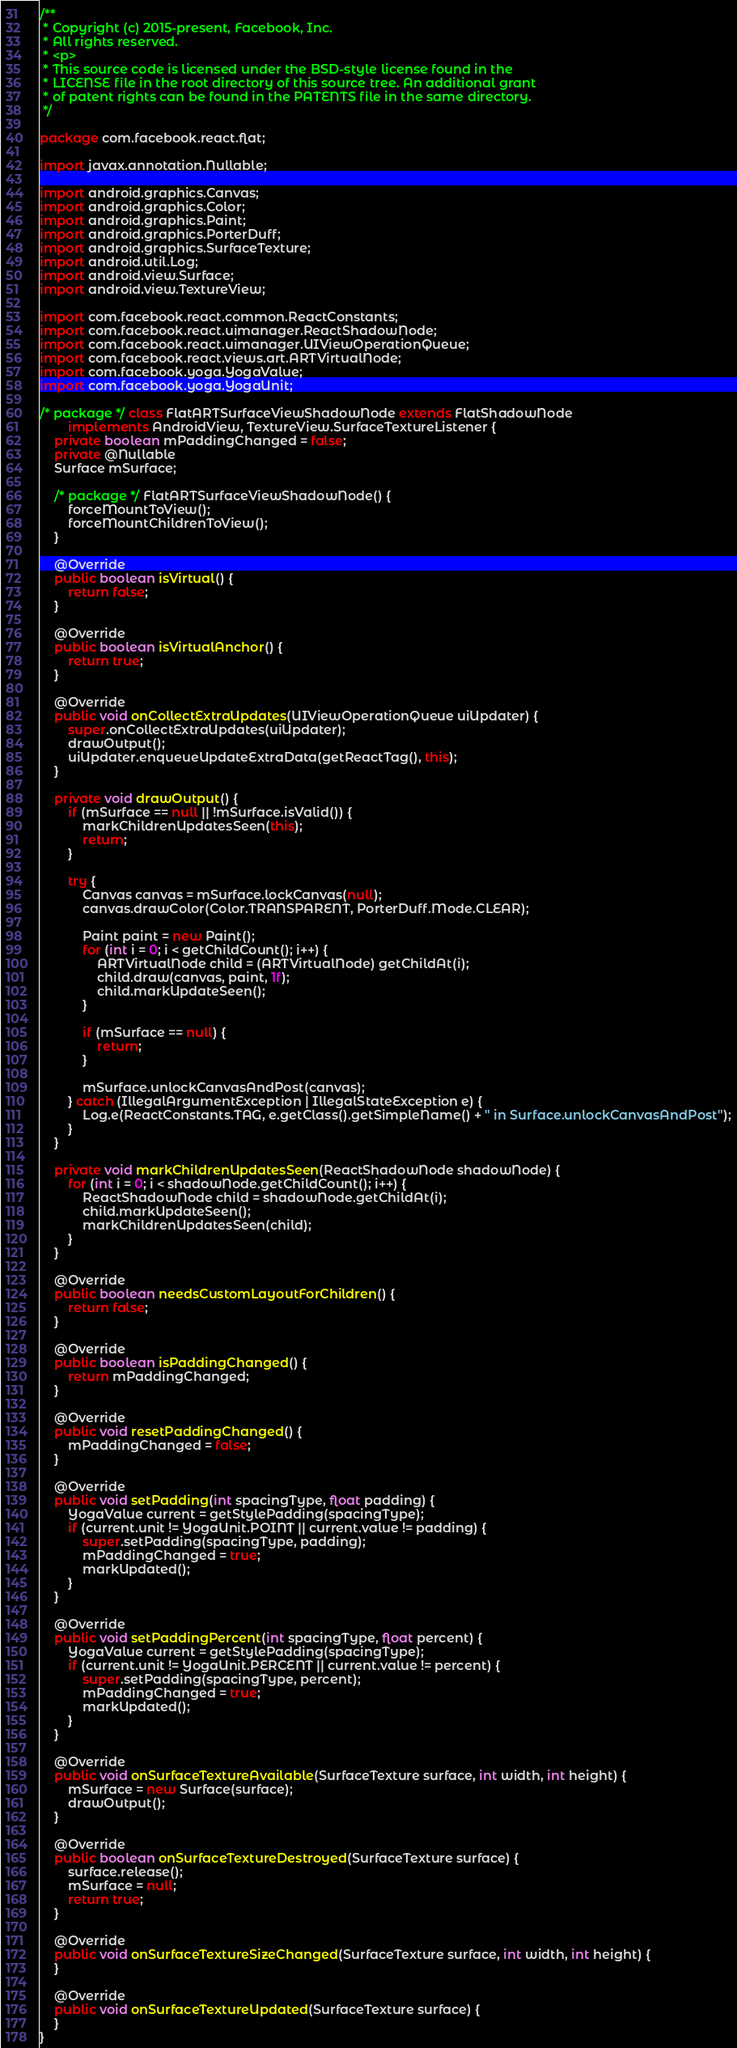<code> <loc_0><loc_0><loc_500><loc_500><_Java_>/**
 * Copyright (c) 2015-present, Facebook, Inc.
 * All rights reserved.
 * <p>
 * This source code is licensed under the BSD-style license found in the
 * LICENSE file in the root directory of this source tree. An additional grant
 * of patent rights can be found in the PATENTS file in the same directory.
 */

package com.facebook.react.flat;

import javax.annotation.Nullable;

import android.graphics.Canvas;
import android.graphics.Color;
import android.graphics.Paint;
import android.graphics.PorterDuff;
import android.graphics.SurfaceTexture;
import android.util.Log;
import android.view.Surface;
import android.view.TextureView;

import com.facebook.react.common.ReactConstants;
import com.facebook.react.uimanager.ReactShadowNode;
import com.facebook.react.uimanager.UIViewOperationQueue;
import com.facebook.react.views.art.ARTVirtualNode;
import com.facebook.yoga.YogaValue;
import com.facebook.yoga.YogaUnit;

/* package */ class FlatARTSurfaceViewShadowNode extends FlatShadowNode
        implements AndroidView, TextureView.SurfaceTextureListener {
    private boolean mPaddingChanged = false;
    private @Nullable
    Surface mSurface;

    /* package */ FlatARTSurfaceViewShadowNode() {
        forceMountToView();
        forceMountChildrenToView();
    }

    @Override
    public boolean isVirtual() {
        return false;
    }

    @Override
    public boolean isVirtualAnchor() {
        return true;
    }

    @Override
    public void onCollectExtraUpdates(UIViewOperationQueue uiUpdater) {
        super.onCollectExtraUpdates(uiUpdater);
        drawOutput();
        uiUpdater.enqueueUpdateExtraData(getReactTag(), this);
    }

    private void drawOutput() {
        if (mSurface == null || !mSurface.isValid()) {
            markChildrenUpdatesSeen(this);
            return;
        }

        try {
            Canvas canvas = mSurface.lockCanvas(null);
            canvas.drawColor(Color.TRANSPARENT, PorterDuff.Mode.CLEAR);

            Paint paint = new Paint();
            for (int i = 0; i < getChildCount(); i++) {
                ARTVirtualNode child = (ARTVirtualNode) getChildAt(i);
                child.draw(canvas, paint, 1f);
                child.markUpdateSeen();
            }

            if (mSurface == null) {
                return;
            }

            mSurface.unlockCanvasAndPost(canvas);
        } catch (IllegalArgumentException | IllegalStateException e) {
            Log.e(ReactConstants.TAG, e.getClass().getSimpleName() + " in Surface.unlockCanvasAndPost");
        }
    }

    private void markChildrenUpdatesSeen(ReactShadowNode shadowNode) {
        for (int i = 0; i < shadowNode.getChildCount(); i++) {
            ReactShadowNode child = shadowNode.getChildAt(i);
            child.markUpdateSeen();
            markChildrenUpdatesSeen(child);
        }
    }

    @Override
    public boolean needsCustomLayoutForChildren() {
        return false;
    }

    @Override
    public boolean isPaddingChanged() {
        return mPaddingChanged;
    }

    @Override
    public void resetPaddingChanged() {
        mPaddingChanged = false;
    }

    @Override
    public void setPadding(int spacingType, float padding) {
        YogaValue current = getStylePadding(spacingType);
        if (current.unit != YogaUnit.POINT || current.value != padding) {
            super.setPadding(spacingType, padding);
            mPaddingChanged = true;
            markUpdated();
        }
    }

    @Override
    public void setPaddingPercent(int spacingType, float percent) {
        YogaValue current = getStylePadding(spacingType);
        if (current.unit != YogaUnit.PERCENT || current.value != percent) {
            super.setPadding(spacingType, percent);
            mPaddingChanged = true;
            markUpdated();
        }
    }

    @Override
    public void onSurfaceTextureAvailable(SurfaceTexture surface, int width, int height) {
        mSurface = new Surface(surface);
        drawOutput();
    }

    @Override
    public boolean onSurfaceTextureDestroyed(SurfaceTexture surface) {
        surface.release();
        mSurface = null;
        return true;
    }

    @Override
    public void onSurfaceTextureSizeChanged(SurfaceTexture surface, int width, int height) {
    }

    @Override
    public void onSurfaceTextureUpdated(SurfaceTexture surface) {
    }
}
</code> 